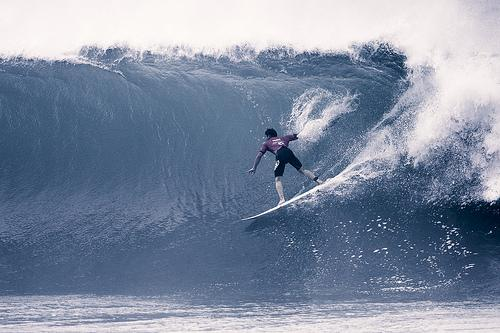What sentiment or emotion is conveyed by this image? The image conveys a sense of thrill and adventure. Briefly describe the condition of the ocean water just before the wave breaks. The ocean water is calm and serene before the wave starts to crest. Provide a general observation of the scene depicted in the image. This is an image of a surfer riding a massive wave, with the wave's white foam, a calm ocean, and clear skies in the background. How many unique descriptions are given for the main subject in the image (the person)? 9 unique descriptions Analyze the interaction between the surfer and the wave. The surfer is skillfully navigating the breaking wave while maintaining balance; his left arm makes contact with the wave, creating a circle of white water. What is the primary color of the surfer's wetsuit? The surfer is wearing a purple and black wetsuit. Express the excitement and intensity of the image using descriptive language. A daring surfer rides a colossal, powerful wave with skill and precision, slicing through the frothy water beneath a clear, open sky. What is distinctive about the surfer's posture while riding the wave? The surfer has his arms and legs spread apart for balance and is touching the wave as he rides along. Describe the stylish elements present on the surfer's clothing. white writing and design on wetsuit Which of the following objects is involved in the activity being performed: man playing in water, surfboard tethered to ankle, or strap used to attach man to surfboard? surfboard tethered to ankle Point out the visual entailment of the surfboard's movement through the water. path surfboard cut in the wave Offer a brief description of the surfer's position on the wave. surfer slanting downwards on board, arms and legs spread apart How does the surfer interact with the wall of the wave? surfer touching the wall of the wave with his hand What contrasting colors are present in the overall wave formation? deeper blue of curve and white foam Can you find a lighthouse in the background of the image, located at the far-right side?  No, it's not mentioned in the image. Compose a short poem that encompasses the atmosphere of the image. Cresting waves rise high and free, Identify the phase of the wave immediately behind the surfer. wave breaking What causes the circle of white water in the image? surfer's arm creating foam Identify the ongoing event in the image. Surfer riding a huge whitecapped wave Give a detailed description of the surfboard's appearance. light colored, white surfboard cutting through the wave with strap tethered to ankle Identify the source of the white ocean spray in the image. surfer's hand and breaking wave Describe the overall scene and atmosphere of the image with focus on both the surfer and the ocean. A surfer in a purple and black wetsuit expertly riding a huge whitecapped wave, maintaining balance with arms and legs spread apart, while calm ocean water lies ahead in contrast. Explain the calm sea area of the image in a sentence. Calm sea in front of the surfer, contrasting the breaking wave Describe the surfboarder's outfit in a single, flowing sentence. The surfboarder is wearing a purple and black wetsuit with white writing and design on it. Compare and contrast the appearance of the water in different parts of the image. whitecapped wave with ruffled edge, trough of wave with calm ocean water before it breaks How is the surfer maintaining balance while riding the wave? arms out, legs spread apart Which of the following statements is true regarding the wave: wave about to crash, wave just starting to crest, or white foam of wave being ridden? white foam of wave being ridden What is the main color of the surfer's wetsuit? purple and black 